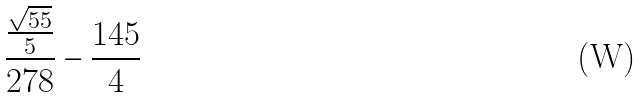<formula> <loc_0><loc_0><loc_500><loc_500>\frac { \frac { \sqrt { 5 5 } } { 5 } } { 2 7 8 } - \frac { 1 4 5 } { 4 }</formula> 